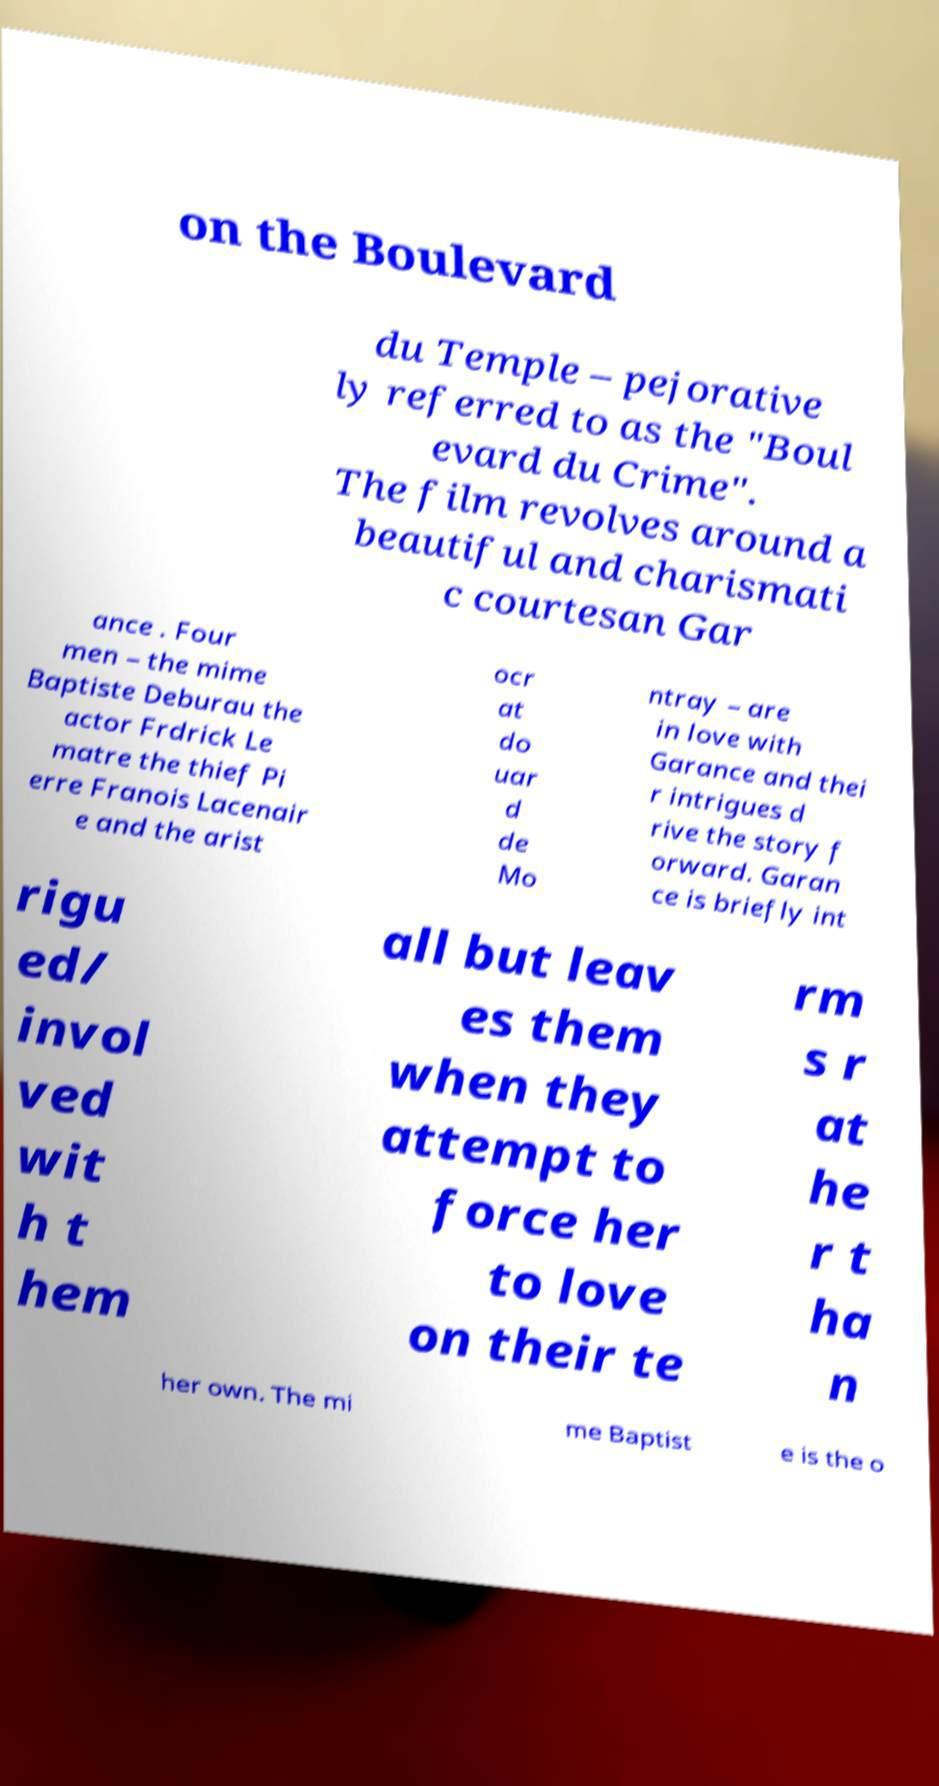Can you read and provide the text displayed in the image?This photo seems to have some interesting text. Can you extract and type it out for me? on the Boulevard du Temple – pejorative ly referred to as the "Boul evard du Crime". The film revolves around a beautiful and charismati c courtesan Gar ance . Four men – the mime Baptiste Deburau the actor Frdrick Le matre the thief Pi erre Franois Lacenair e and the arist ocr at do uar d de Mo ntray – are in love with Garance and thei r intrigues d rive the story f orward. Garan ce is briefly int rigu ed/ invol ved wit h t hem all but leav es them when they attempt to force her to love on their te rm s r at he r t ha n her own. The mi me Baptist e is the o 